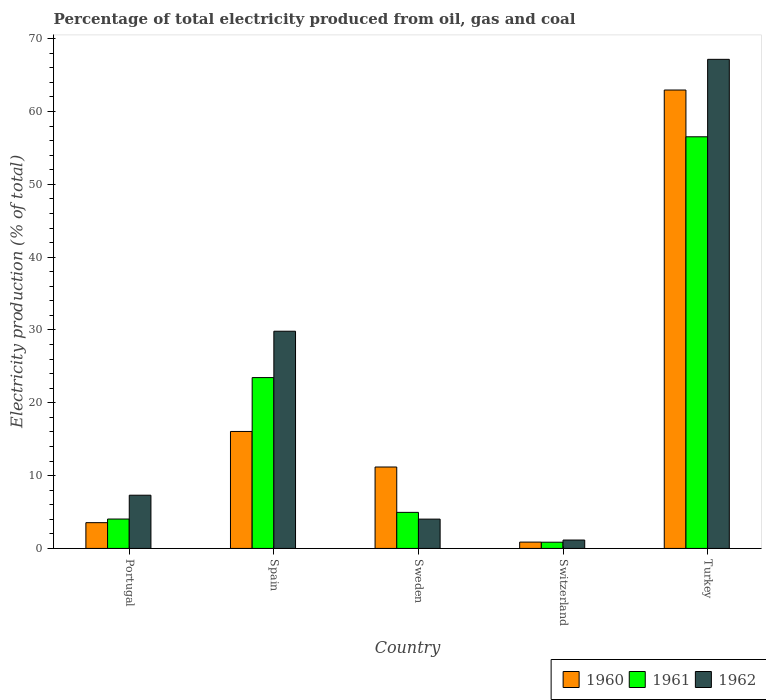How many different coloured bars are there?
Your response must be concise. 3. How many bars are there on the 3rd tick from the right?
Give a very brief answer. 3. What is the electricity production in in 1960 in Spain?
Provide a succinct answer. 16.06. Across all countries, what is the maximum electricity production in in 1961?
Your response must be concise. 56.53. Across all countries, what is the minimum electricity production in in 1960?
Provide a short and direct response. 0.87. In which country was the electricity production in in 1960 minimum?
Provide a short and direct response. Switzerland. What is the total electricity production in in 1960 in the graph?
Give a very brief answer. 94.6. What is the difference between the electricity production in in 1962 in Portugal and that in Sweden?
Give a very brief answer. 3.28. What is the difference between the electricity production in in 1960 in Switzerland and the electricity production in in 1961 in Turkey?
Give a very brief answer. -55.66. What is the average electricity production in in 1961 per country?
Keep it short and to the point. 17.97. What is the difference between the electricity production in of/in 1962 and electricity production in of/in 1961 in Spain?
Your response must be concise. 6.37. What is the ratio of the electricity production in in 1961 in Spain to that in Sweden?
Give a very brief answer. 4.74. Is the electricity production in in 1961 in Portugal less than that in Turkey?
Make the answer very short. Yes. What is the difference between the highest and the second highest electricity production in in 1960?
Offer a very short reply. 4.88. What is the difference between the highest and the lowest electricity production in in 1962?
Your answer should be compact. 66.01. Is the sum of the electricity production in in 1960 in Portugal and Spain greater than the maximum electricity production in in 1962 across all countries?
Offer a terse response. No. Are all the bars in the graph horizontal?
Provide a succinct answer. No. How many countries are there in the graph?
Your answer should be compact. 5. What is the difference between two consecutive major ticks on the Y-axis?
Make the answer very short. 10. Does the graph contain any zero values?
Your answer should be very brief. No. Where does the legend appear in the graph?
Provide a short and direct response. Bottom right. How many legend labels are there?
Provide a short and direct response. 3. What is the title of the graph?
Provide a succinct answer. Percentage of total electricity produced from oil, gas and coal. Does "1998" appear as one of the legend labels in the graph?
Make the answer very short. No. What is the label or title of the X-axis?
Ensure brevity in your answer.  Country. What is the label or title of the Y-axis?
Provide a succinct answer. Electricity production (% of total). What is the Electricity production (% of total) of 1960 in Portugal?
Give a very brief answer. 3.54. What is the Electricity production (% of total) in 1961 in Portugal?
Your answer should be very brief. 4.04. What is the Electricity production (% of total) in 1962 in Portugal?
Make the answer very short. 7.31. What is the Electricity production (% of total) of 1960 in Spain?
Make the answer very short. 16.06. What is the Electricity production (% of total) in 1961 in Spain?
Your answer should be compact. 23.46. What is the Electricity production (% of total) in 1962 in Spain?
Give a very brief answer. 29.83. What is the Electricity production (% of total) in 1960 in Sweden?
Provide a succinct answer. 11.18. What is the Electricity production (% of total) in 1961 in Sweden?
Provide a short and direct response. 4.95. What is the Electricity production (% of total) in 1962 in Sweden?
Provide a short and direct response. 4.02. What is the Electricity production (% of total) in 1960 in Switzerland?
Offer a terse response. 0.87. What is the Electricity production (% of total) of 1961 in Switzerland?
Offer a terse response. 0.85. What is the Electricity production (% of total) in 1962 in Switzerland?
Ensure brevity in your answer.  1.15. What is the Electricity production (% of total) of 1960 in Turkey?
Your answer should be compact. 62.95. What is the Electricity production (% of total) in 1961 in Turkey?
Make the answer very short. 56.53. What is the Electricity production (% of total) of 1962 in Turkey?
Offer a very short reply. 67.16. Across all countries, what is the maximum Electricity production (% of total) of 1960?
Keep it short and to the point. 62.95. Across all countries, what is the maximum Electricity production (% of total) in 1961?
Your answer should be compact. 56.53. Across all countries, what is the maximum Electricity production (% of total) in 1962?
Offer a very short reply. 67.16. Across all countries, what is the minimum Electricity production (% of total) in 1960?
Give a very brief answer. 0.87. Across all countries, what is the minimum Electricity production (% of total) in 1961?
Make the answer very short. 0.85. Across all countries, what is the minimum Electricity production (% of total) of 1962?
Make the answer very short. 1.15. What is the total Electricity production (% of total) in 1960 in the graph?
Give a very brief answer. 94.6. What is the total Electricity production (% of total) in 1961 in the graph?
Make the answer very short. 89.83. What is the total Electricity production (% of total) in 1962 in the graph?
Provide a succinct answer. 109.48. What is the difference between the Electricity production (% of total) in 1960 in Portugal and that in Spain?
Keep it short and to the point. -12.53. What is the difference between the Electricity production (% of total) of 1961 in Portugal and that in Spain?
Provide a short and direct response. -19.42. What is the difference between the Electricity production (% of total) in 1962 in Portugal and that in Spain?
Offer a terse response. -22.52. What is the difference between the Electricity production (% of total) in 1960 in Portugal and that in Sweden?
Provide a succinct answer. -7.64. What is the difference between the Electricity production (% of total) in 1961 in Portugal and that in Sweden?
Provide a short and direct response. -0.92. What is the difference between the Electricity production (% of total) of 1962 in Portugal and that in Sweden?
Provide a succinct answer. 3.28. What is the difference between the Electricity production (% of total) of 1960 in Portugal and that in Switzerland?
Provide a short and direct response. 2.67. What is the difference between the Electricity production (% of total) of 1961 in Portugal and that in Switzerland?
Make the answer very short. 3.18. What is the difference between the Electricity production (% of total) in 1962 in Portugal and that in Switzerland?
Keep it short and to the point. 6.16. What is the difference between the Electricity production (% of total) of 1960 in Portugal and that in Turkey?
Give a very brief answer. -59.41. What is the difference between the Electricity production (% of total) in 1961 in Portugal and that in Turkey?
Your response must be concise. -52.49. What is the difference between the Electricity production (% of total) in 1962 in Portugal and that in Turkey?
Give a very brief answer. -59.85. What is the difference between the Electricity production (% of total) of 1960 in Spain and that in Sweden?
Provide a succinct answer. 4.88. What is the difference between the Electricity production (% of total) of 1961 in Spain and that in Sweden?
Offer a terse response. 18.51. What is the difference between the Electricity production (% of total) of 1962 in Spain and that in Sweden?
Offer a terse response. 25.8. What is the difference between the Electricity production (% of total) in 1960 in Spain and that in Switzerland?
Your response must be concise. 15.19. What is the difference between the Electricity production (% of total) in 1961 in Spain and that in Switzerland?
Keep it short and to the point. 22.61. What is the difference between the Electricity production (% of total) of 1962 in Spain and that in Switzerland?
Make the answer very short. 28.67. What is the difference between the Electricity production (% of total) of 1960 in Spain and that in Turkey?
Your answer should be compact. -46.89. What is the difference between the Electricity production (% of total) of 1961 in Spain and that in Turkey?
Your response must be concise. -33.07. What is the difference between the Electricity production (% of total) in 1962 in Spain and that in Turkey?
Ensure brevity in your answer.  -37.34. What is the difference between the Electricity production (% of total) in 1960 in Sweden and that in Switzerland?
Your answer should be compact. 10.31. What is the difference between the Electricity production (% of total) of 1961 in Sweden and that in Switzerland?
Your answer should be very brief. 4.1. What is the difference between the Electricity production (% of total) of 1962 in Sweden and that in Switzerland?
Provide a short and direct response. 2.87. What is the difference between the Electricity production (% of total) of 1960 in Sweden and that in Turkey?
Provide a short and direct response. -51.77. What is the difference between the Electricity production (% of total) in 1961 in Sweden and that in Turkey?
Provide a short and direct response. -51.57. What is the difference between the Electricity production (% of total) in 1962 in Sweden and that in Turkey?
Ensure brevity in your answer.  -63.14. What is the difference between the Electricity production (% of total) of 1960 in Switzerland and that in Turkey?
Offer a terse response. -62.08. What is the difference between the Electricity production (% of total) of 1961 in Switzerland and that in Turkey?
Offer a very short reply. -55.67. What is the difference between the Electricity production (% of total) in 1962 in Switzerland and that in Turkey?
Make the answer very short. -66.01. What is the difference between the Electricity production (% of total) of 1960 in Portugal and the Electricity production (% of total) of 1961 in Spain?
Offer a terse response. -19.92. What is the difference between the Electricity production (% of total) of 1960 in Portugal and the Electricity production (% of total) of 1962 in Spain?
Make the answer very short. -26.29. What is the difference between the Electricity production (% of total) in 1961 in Portugal and the Electricity production (% of total) in 1962 in Spain?
Your answer should be very brief. -25.79. What is the difference between the Electricity production (% of total) in 1960 in Portugal and the Electricity production (% of total) in 1961 in Sweden?
Your response must be concise. -1.41. What is the difference between the Electricity production (% of total) of 1960 in Portugal and the Electricity production (% of total) of 1962 in Sweden?
Make the answer very short. -0.49. What is the difference between the Electricity production (% of total) in 1961 in Portugal and the Electricity production (% of total) in 1962 in Sweden?
Make the answer very short. 0.01. What is the difference between the Electricity production (% of total) in 1960 in Portugal and the Electricity production (% of total) in 1961 in Switzerland?
Give a very brief answer. 2.68. What is the difference between the Electricity production (% of total) in 1960 in Portugal and the Electricity production (% of total) in 1962 in Switzerland?
Your response must be concise. 2.38. What is the difference between the Electricity production (% of total) of 1961 in Portugal and the Electricity production (% of total) of 1962 in Switzerland?
Keep it short and to the point. 2.88. What is the difference between the Electricity production (% of total) in 1960 in Portugal and the Electricity production (% of total) in 1961 in Turkey?
Provide a short and direct response. -52.99. What is the difference between the Electricity production (% of total) in 1960 in Portugal and the Electricity production (% of total) in 1962 in Turkey?
Your response must be concise. -63.63. What is the difference between the Electricity production (% of total) of 1961 in Portugal and the Electricity production (% of total) of 1962 in Turkey?
Provide a short and direct response. -63.13. What is the difference between the Electricity production (% of total) of 1960 in Spain and the Electricity production (% of total) of 1961 in Sweden?
Give a very brief answer. 11.11. What is the difference between the Electricity production (% of total) in 1960 in Spain and the Electricity production (% of total) in 1962 in Sweden?
Provide a succinct answer. 12.04. What is the difference between the Electricity production (% of total) of 1961 in Spain and the Electricity production (% of total) of 1962 in Sweden?
Make the answer very short. 19.44. What is the difference between the Electricity production (% of total) in 1960 in Spain and the Electricity production (% of total) in 1961 in Switzerland?
Ensure brevity in your answer.  15.21. What is the difference between the Electricity production (% of total) of 1960 in Spain and the Electricity production (% of total) of 1962 in Switzerland?
Keep it short and to the point. 14.91. What is the difference between the Electricity production (% of total) in 1961 in Spain and the Electricity production (% of total) in 1962 in Switzerland?
Your response must be concise. 22.31. What is the difference between the Electricity production (% of total) in 1960 in Spain and the Electricity production (% of total) in 1961 in Turkey?
Provide a succinct answer. -40.46. What is the difference between the Electricity production (% of total) in 1960 in Spain and the Electricity production (% of total) in 1962 in Turkey?
Provide a short and direct response. -51.1. What is the difference between the Electricity production (% of total) in 1961 in Spain and the Electricity production (% of total) in 1962 in Turkey?
Keep it short and to the point. -43.7. What is the difference between the Electricity production (% of total) of 1960 in Sweden and the Electricity production (% of total) of 1961 in Switzerland?
Give a very brief answer. 10.33. What is the difference between the Electricity production (% of total) of 1960 in Sweden and the Electricity production (% of total) of 1962 in Switzerland?
Your answer should be very brief. 10.03. What is the difference between the Electricity production (% of total) of 1961 in Sweden and the Electricity production (% of total) of 1962 in Switzerland?
Provide a succinct answer. 3.8. What is the difference between the Electricity production (% of total) in 1960 in Sweden and the Electricity production (% of total) in 1961 in Turkey?
Provide a succinct answer. -45.35. What is the difference between the Electricity production (% of total) of 1960 in Sweden and the Electricity production (% of total) of 1962 in Turkey?
Your response must be concise. -55.98. What is the difference between the Electricity production (% of total) in 1961 in Sweden and the Electricity production (% of total) in 1962 in Turkey?
Your answer should be compact. -62.21. What is the difference between the Electricity production (% of total) in 1960 in Switzerland and the Electricity production (% of total) in 1961 in Turkey?
Offer a very short reply. -55.66. What is the difference between the Electricity production (% of total) in 1960 in Switzerland and the Electricity production (% of total) in 1962 in Turkey?
Your response must be concise. -66.29. What is the difference between the Electricity production (% of total) of 1961 in Switzerland and the Electricity production (% of total) of 1962 in Turkey?
Ensure brevity in your answer.  -66.31. What is the average Electricity production (% of total) of 1960 per country?
Provide a short and direct response. 18.92. What is the average Electricity production (% of total) of 1961 per country?
Give a very brief answer. 17.97. What is the average Electricity production (% of total) in 1962 per country?
Provide a succinct answer. 21.9. What is the difference between the Electricity production (% of total) in 1960 and Electricity production (% of total) in 1961 in Portugal?
Give a very brief answer. -0.5. What is the difference between the Electricity production (% of total) in 1960 and Electricity production (% of total) in 1962 in Portugal?
Ensure brevity in your answer.  -3.77. What is the difference between the Electricity production (% of total) in 1961 and Electricity production (% of total) in 1962 in Portugal?
Offer a very short reply. -3.27. What is the difference between the Electricity production (% of total) of 1960 and Electricity production (% of total) of 1961 in Spain?
Offer a very short reply. -7.4. What is the difference between the Electricity production (% of total) of 1960 and Electricity production (% of total) of 1962 in Spain?
Offer a very short reply. -13.76. What is the difference between the Electricity production (% of total) of 1961 and Electricity production (% of total) of 1962 in Spain?
Ensure brevity in your answer.  -6.37. What is the difference between the Electricity production (% of total) in 1960 and Electricity production (% of total) in 1961 in Sweden?
Keep it short and to the point. 6.23. What is the difference between the Electricity production (% of total) in 1960 and Electricity production (% of total) in 1962 in Sweden?
Your answer should be very brief. 7.16. What is the difference between the Electricity production (% of total) of 1961 and Electricity production (% of total) of 1962 in Sweden?
Your answer should be very brief. 0.93. What is the difference between the Electricity production (% of total) of 1960 and Electricity production (% of total) of 1961 in Switzerland?
Your response must be concise. 0.02. What is the difference between the Electricity production (% of total) in 1960 and Electricity production (% of total) in 1962 in Switzerland?
Ensure brevity in your answer.  -0.28. What is the difference between the Electricity production (% of total) of 1961 and Electricity production (% of total) of 1962 in Switzerland?
Offer a very short reply. -0.3. What is the difference between the Electricity production (% of total) in 1960 and Electricity production (% of total) in 1961 in Turkey?
Offer a very short reply. 6.42. What is the difference between the Electricity production (% of total) of 1960 and Electricity production (% of total) of 1962 in Turkey?
Your answer should be compact. -4.21. What is the difference between the Electricity production (% of total) in 1961 and Electricity production (% of total) in 1962 in Turkey?
Offer a very short reply. -10.64. What is the ratio of the Electricity production (% of total) in 1960 in Portugal to that in Spain?
Provide a succinct answer. 0.22. What is the ratio of the Electricity production (% of total) of 1961 in Portugal to that in Spain?
Your answer should be compact. 0.17. What is the ratio of the Electricity production (% of total) of 1962 in Portugal to that in Spain?
Provide a succinct answer. 0.24. What is the ratio of the Electricity production (% of total) of 1960 in Portugal to that in Sweden?
Provide a succinct answer. 0.32. What is the ratio of the Electricity production (% of total) in 1961 in Portugal to that in Sweden?
Offer a very short reply. 0.82. What is the ratio of the Electricity production (% of total) in 1962 in Portugal to that in Sweden?
Your answer should be compact. 1.82. What is the ratio of the Electricity production (% of total) in 1960 in Portugal to that in Switzerland?
Make the answer very short. 4.07. What is the ratio of the Electricity production (% of total) in 1961 in Portugal to that in Switzerland?
Ensure brevity in your answer.  4.73. What is the ratio of the Electricity production (% of total) in 1962 in Portugal to that in Switzerland?
Provide a short and direct response. 6.34. What is the ratio of the Electricity production (% of total) in 1960 in Portugal to that in Turkey?
Make the answer very short. 0.06. What is the ratio of the Electricity production (% of total) in 1961 in Portugal to that in Turkey?
Your response must be concise. 0.07. What is the ratio of the Electricity production (% of total) in 1962 in Portugal to that in Turkey?
Ensure brevity in your answer.  0.11. What is the ratio of the Electricity production (% of total) in 1960 in Spain to that in Sweden?
Offer a terse response. 1.44. What is the ratio of the Electricity production (% of total) in 1961 in Spain to that in Sweden?
Provide a succinct answer. 4.74. What is the ratio of the Electricity production (% of total) in 1962 in Spain to that in Sweden?
Offer a terse response. 7.41. What is the ratio of the Electricity production (% of total) in 1960 in Spain to that in Switzerland?
Your answer should be very brief. 18.47. What is the ratio of the Electricity production (% of total) of 1961 in Spain to that in Switzerland?
Provide a succinct answer. 27.48. What is the ratio of the Electricity production (% of total) of 1962 in Spain to that in Switzerland?
Ensure brevity in your answer.  25.86. What is the ratio of the Electricity production (% of total) of 1960 in Spain to that in Turkey?
Provide a short and direct response. 0.26. What is the ratio of the Electricity production (% of total) in 1961 in Spain to that in Turkey?
Ensure brevity in your answer.  0.41. What is the ratio of the Electricity production (% of total) of 1962 in Spain to that in Turkey?
Provide a succinct answer. 0.44. What is the ratio of the Electricity production (% of total) in 1960 in Sweden to that in Switzerland?
Your response must be concise. 12.86. What is the ratio of the Electricity production (% of total) of 1961 in Sweden to that in Switzerland?
Provide a succinct answer. 5.8. What is the ratio of the Electricity production (% of total) of 1962 in Sweden to that in Switzerland?
Offer a terse response. 3.49. What is the ratio of the Electricity production (% of total) in 1960 in Sweden to that in Turkey?
Provide a succinct answer. 0.18. What is the ratio of the Electricity production (% of total) of 1961 in Sweden to that in Turkey?
Provide a short and direct response. 0.09. What is the ratio of the Electricity production (% of total) of 1962 in Sweden to that in Turkey?
Keep it short and to the point. 0.06. What is the ratio of the Electricity production (% of total) in 1960 in Switzerland to that in Turkey?
Give a very brief answer. 0.01. What is the ratio of the Electricity production (% of total) in 1961 in Switzerland to that in Turkey?
Your answer should be very brief. 0.02. What is the ratio of the Electricity production (% of total) in 1962 in Switzerland to that in Turkey?
Provide a short and direct response. 0.02. What is the difference between the highest and the second highest Electricity production (% of total) in 1960?
Provide a succinct answer. 46.89. What is the difference between the highest and the second highest Electricity production (% of total) of 1961?
Give a very brief answer. 33.07. What is the difference between the highest and the second highest Electricity production (% of total) of 1962?
Offer a very short reply. 37.34. What is the difference between the highest and the lowest Electricity production (% of total) of 1960?
Offer a very short reply. 62.08. What is the difference between the highest and the lowest Electricity production (% of total) in 1961?
Provide a succinct answer. 55.67. What is the difference between the highest and the lowest Electricity production (% of total) in 1962?
Your response must be concise. 66.01. 